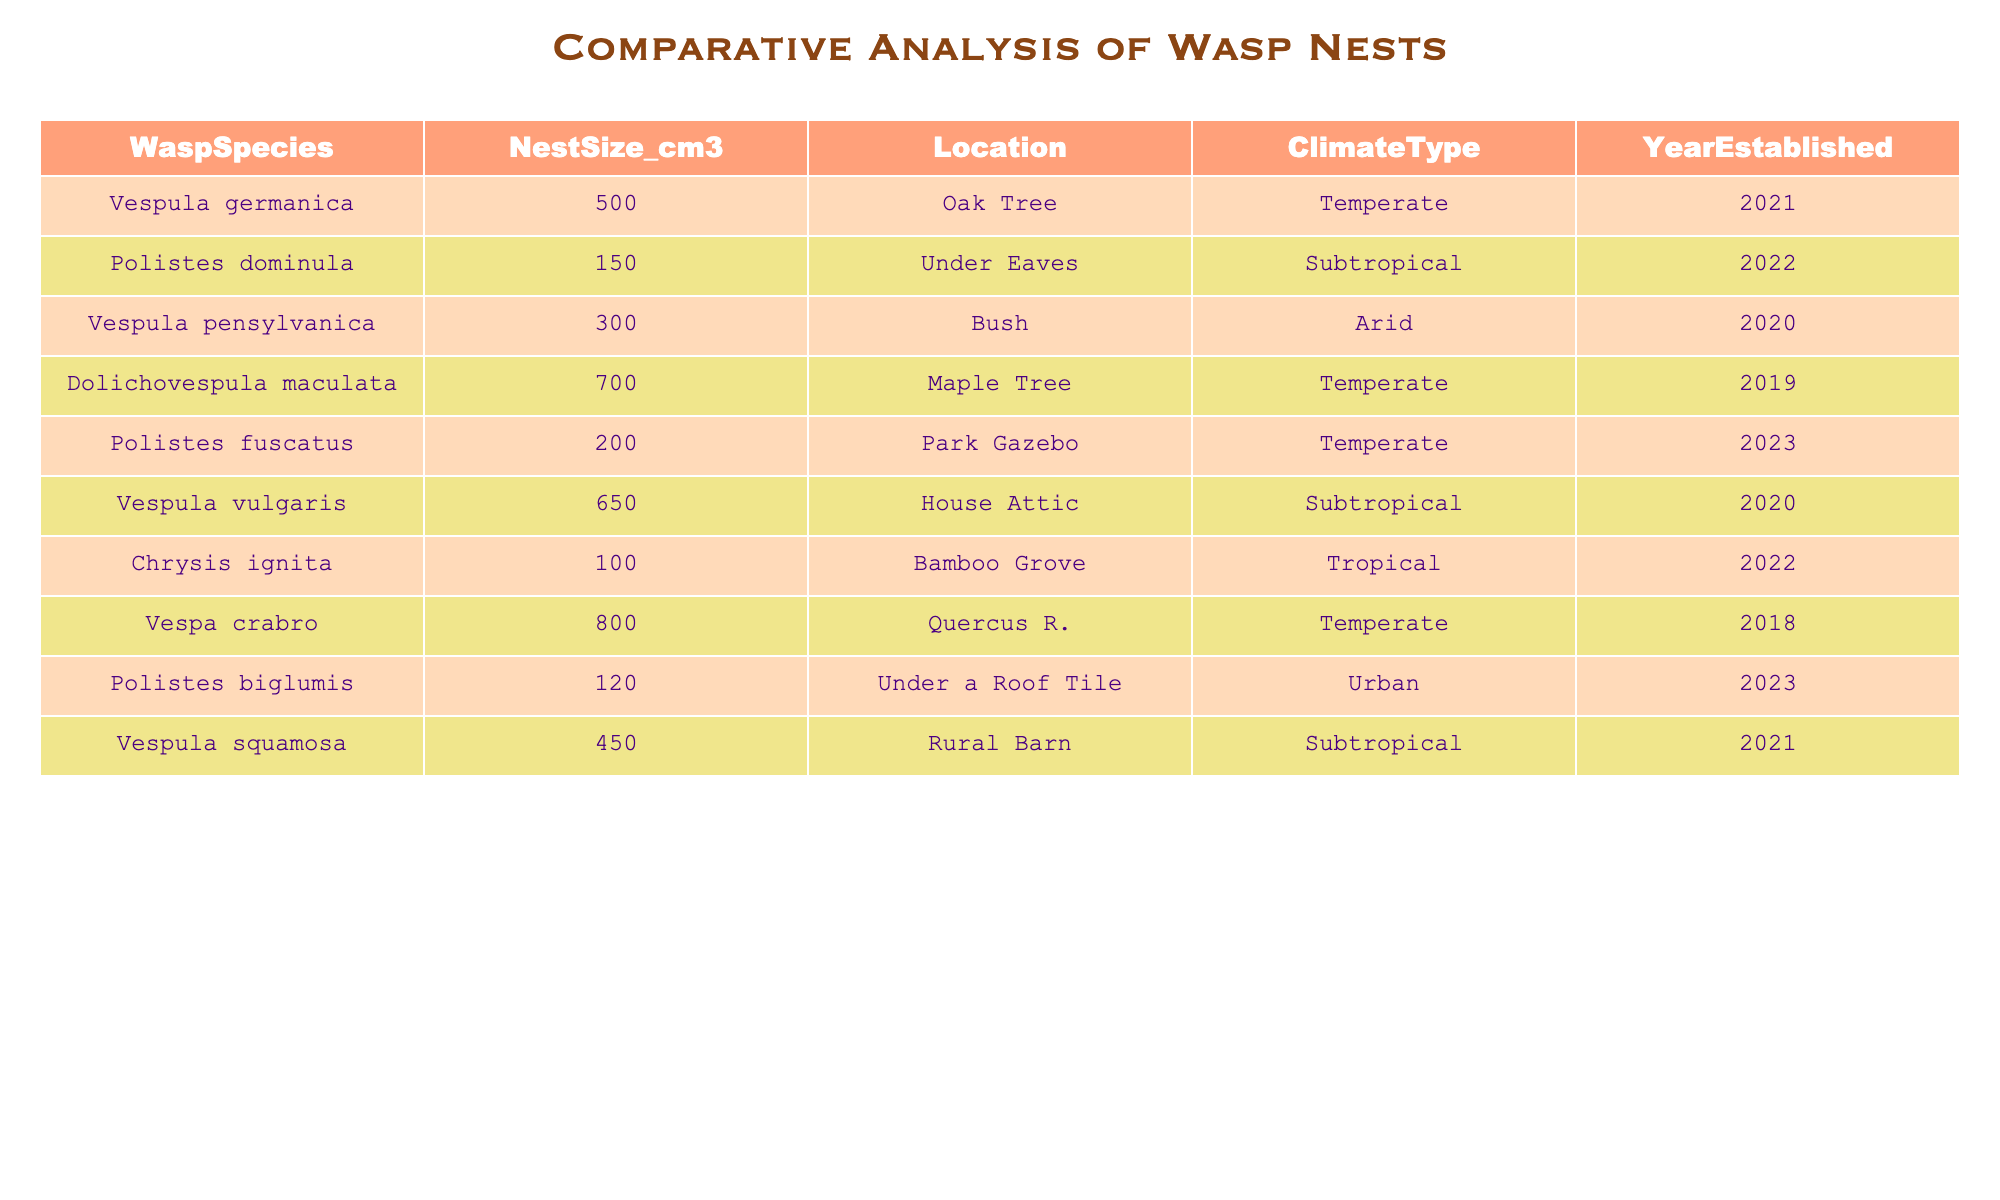What is the largest nest size listed in the table? The table shows various wasp species with their respective nest sizes. By examining the "NestSize_cm3" column, I can identify that Vespa crabro has the largest nest size of 800 cm³.
Answer: 800 cm³ How many wasp nests are established in a temperate climate? Reviewing the "ClimateType" column, I count the nests that are classified as "Temperate." The species are Vespula germanica, Dolichovespula maculata, Polistes fuscatus, and Vespa crabro, which gives a total of 4 nests.
Answer: 4 Which wasp species has the smallest nest size? By examining the "NestSize_cm3" column, I find that Chrysis ignita has the smallest nest size at 100 cm³.
Answer: Chrysis ignita What is the average size of nests established in subtropical climates? I identify the nests established in subtropical climates: Polistes vulgaris (650 cm³), Polistes squamosa (450 cm³), and Polistes dominula (150 cm³). Summing these gives (650 + 450 + 150) = 1250 cm³. Dividing this sum by the 3 nests yields an average size of 1250/3 = 416.67 cm³.
Answer: 416.67 cm³ Is there a wasp nest established in an urban location? I check the "Location" column for entries under "Urban." I find that Polistes biglumis is the only wasp with a nest in an urban location. Therefore, the answer is yes.
Answer: Yes How many of the nests were established after the year 2020? I look at the "YearEstablished" column and spot the years: 2021 (2 nests), 2022 (2 nests), and 2023 (1 nest). Counting these gives a total of 5 nests established after 2020.
Answer: 5 What is the size difference between the largest and smallest nests? From my earlier findings, the largest nest size is from Vespa crabro at 800 cm³ and the smallest is from Chrysis ignita at 100 cm³. The difference is calculated as 800 - 100 = 700 cm³.
Answer: 700 cm³ Which climate type has nests established only in 2022? Upon reviewing the table, I see that Polistes dominula and Polistes biglumis are established in subtropical and urban climates respectively in the year 2023, while the only nest established in 2022 is from Chrysis ignita, which is in a tropical climate. Thus, the answer is tropical climate type.
Answer: Tropical 